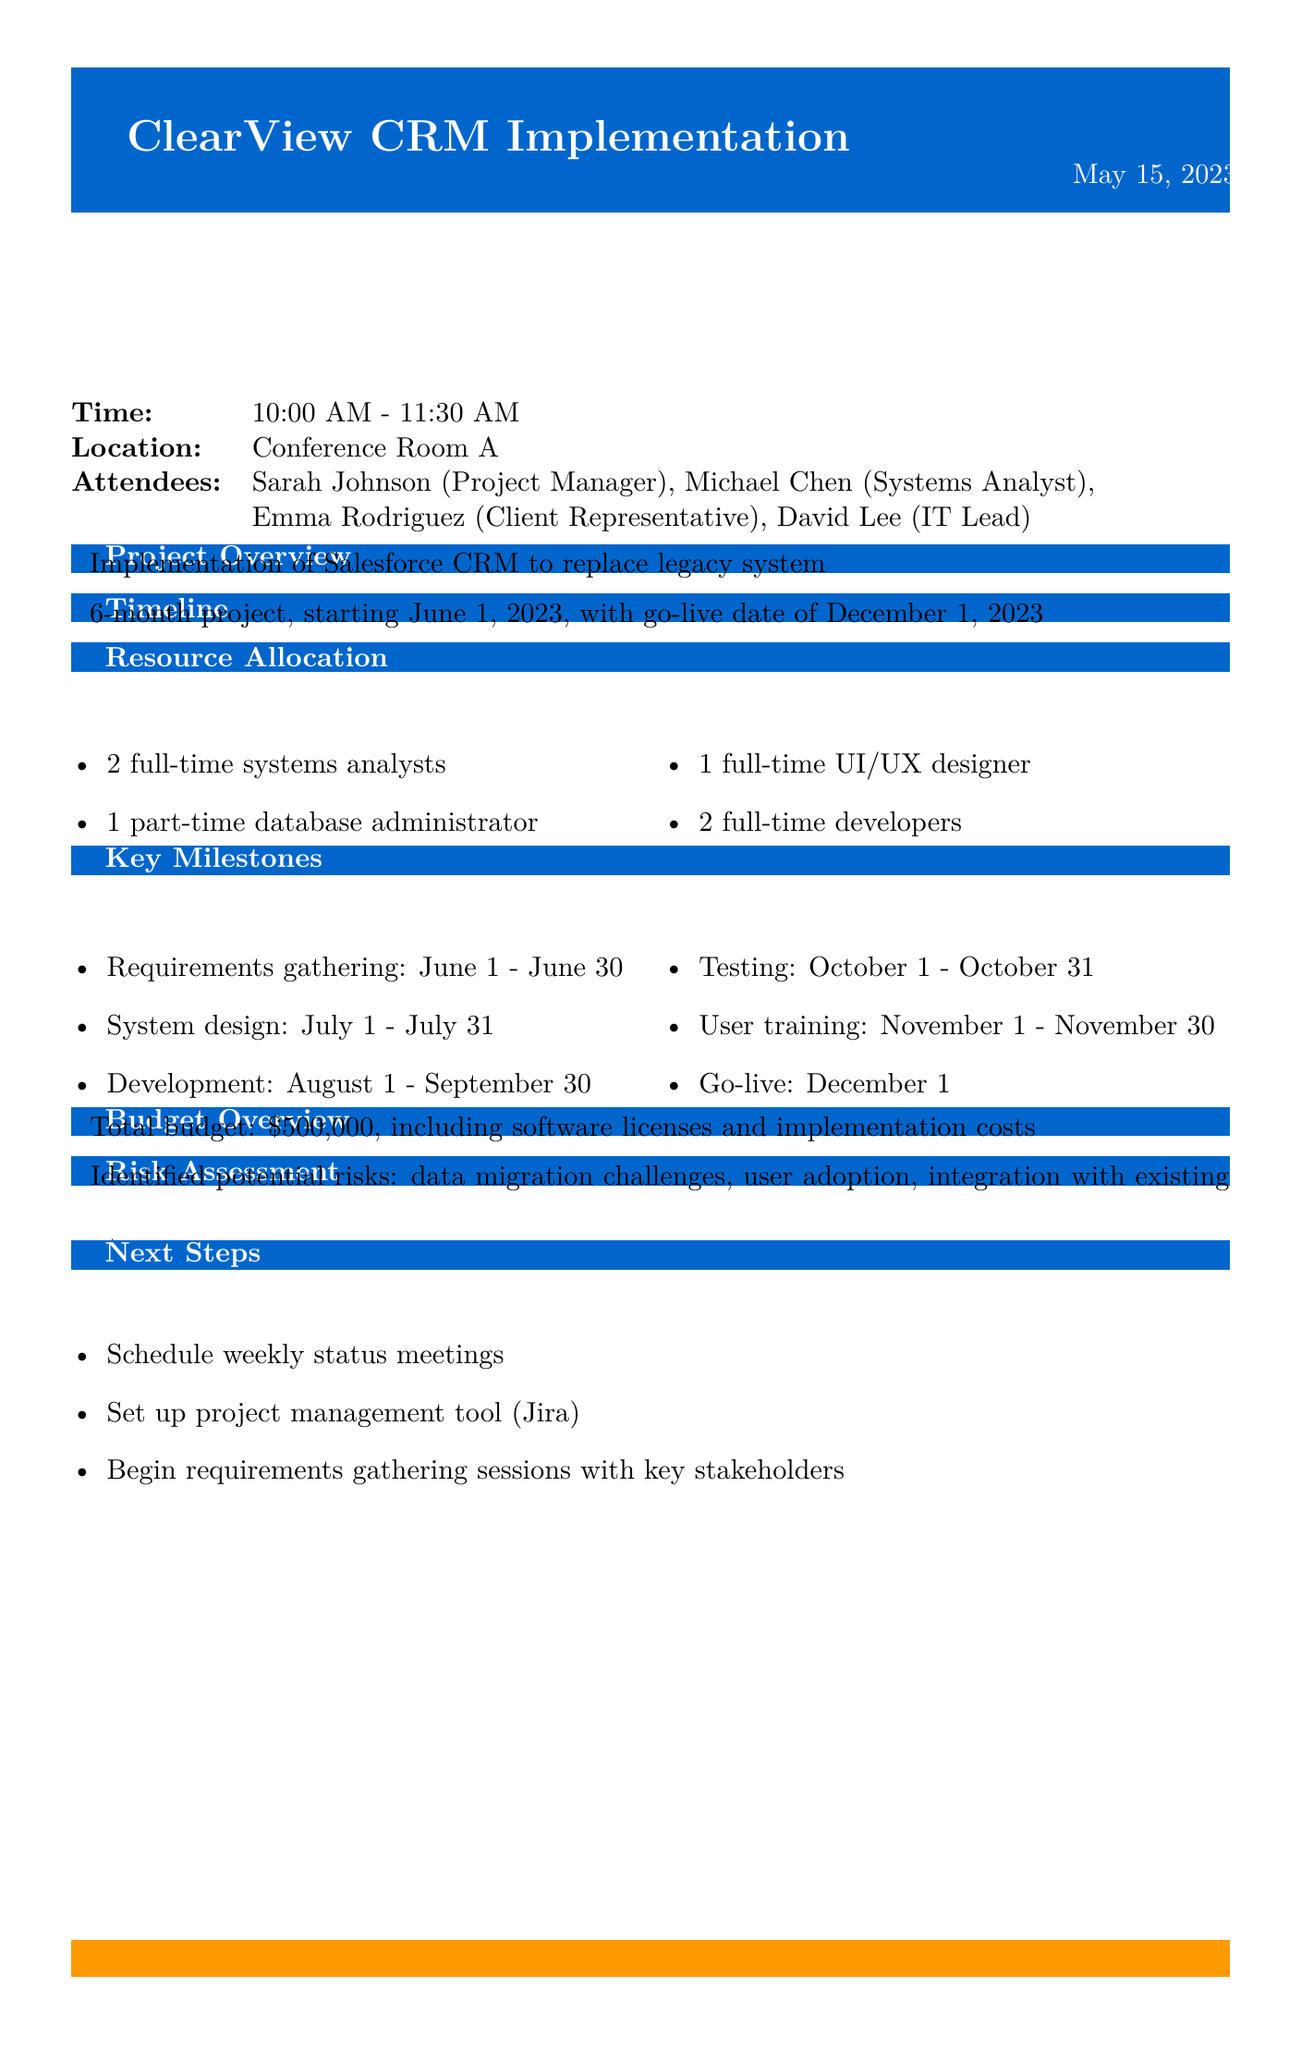What is the project name? The project name is stated in the meeting details section of the document.
Answer: ClearView CRM Implementation Who is the project manager? The name of the project manager is mentioned under the attendees section of the document.
Answer: Sarah Johnson What is the go-live date? The go-live date is mentioned in the timeline section and specifies when the project will be launched.
Answer: December 1, 2023 How long is the project expected to last? The duration of the project is specified in the timeline section of the document.
Answer: 6 months What are the key milestones for the project? This refers to specific phases and their durations as outlined in the document.
Answer: Requirements gathering, System design, Development, Testing, User training, Go-live How many full-time developers are allocated? The resource allocation section provides specific numbers for each role, including developers.
Answer: 2 full-time developers What is the total budget for the project? The total budget is provided in the budget overview section of the document.
Answer: $500,000 What risks were identified during the meeting? The risk assessment section lists potential challenges that the project may face.
Answer: Data migration challenges, user adoption, integration with existing systems What tool is suggested for project management? The next steps section mentions a specific tool for managing the project.
Answer: Jira 